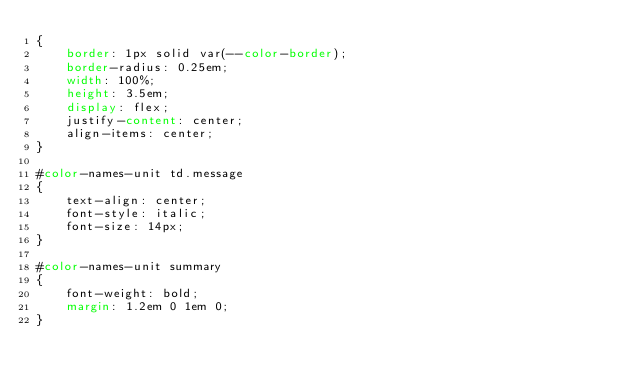Convert code to text. <code><loc_0><loc_0><loc_500><loc_500><_CSS_>{
    border: 1px solid var(--color-border);
    border-radius: 0.25em;
    width: 100%;
    height: 3.5em;
    display: flex;
    justify-content: center;
    align-items: center;
}

#color-names-unit td.message
{
    text-align: center;
    font-style: italic;
    font-size: 14px;
}

#color-names-unit summary
{
    font-weight: bold;
    margin: 1.2em 0 1em 0;
}
</code> 